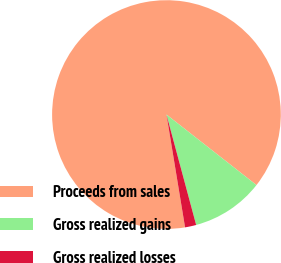Convert chart. <chart><loc_0><loc_0><loc_500><loc_500><pie_chart><fcel>Proceeds from sales<fcel>Gross realized gains<fcel>Gross realized losses<nl><fcel>88.17%<fcel>10.24%<fcel>1.58%<nl></chart> 